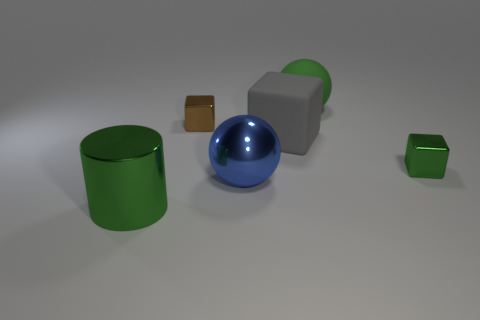How do the shadows in the image inform us about the light source? The shadows in the image are soft and diffusely spread out, indicating that the light source is not a point source but is rather large or distanced, such as a window or overhead lighting with a diffuser. The shadows are consistent, as all objects cast a shadow in the same direction, suggesting a single dominant light source from above and to the left of the scene.  If you had to guess, what time of day would it be based on the lighting present in the image? The image seems to be artificially lit, as indicated by the soft shadows and even lighting, making it difficult to determine a time of day. There's no telltale sign of natural sunlight, such as warm tones or the angle of shadows that might indicate a time of day. It probably represents an indoor scene with controlled lighting conditions. 